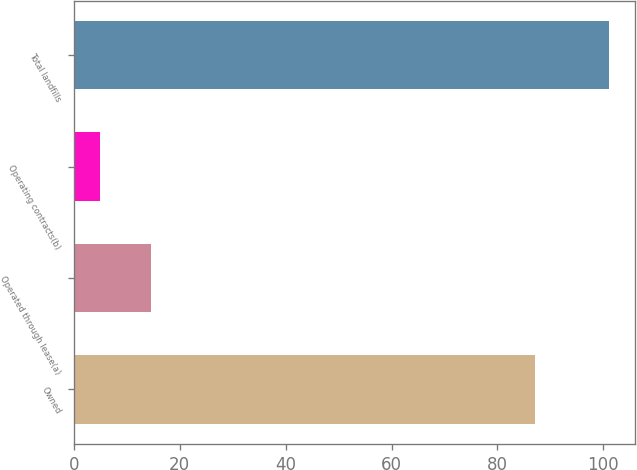<chart> <loc_0><loc_0><loc_500><loc_500><bar_chart><fcel>Owned<fcel>Operated through lease(a)<fcel>Operating contracts(b)<fcel>Total landfills<nl><fcel>87<fcel>14.6<fcel>5<fcel>101<nl></chart> 